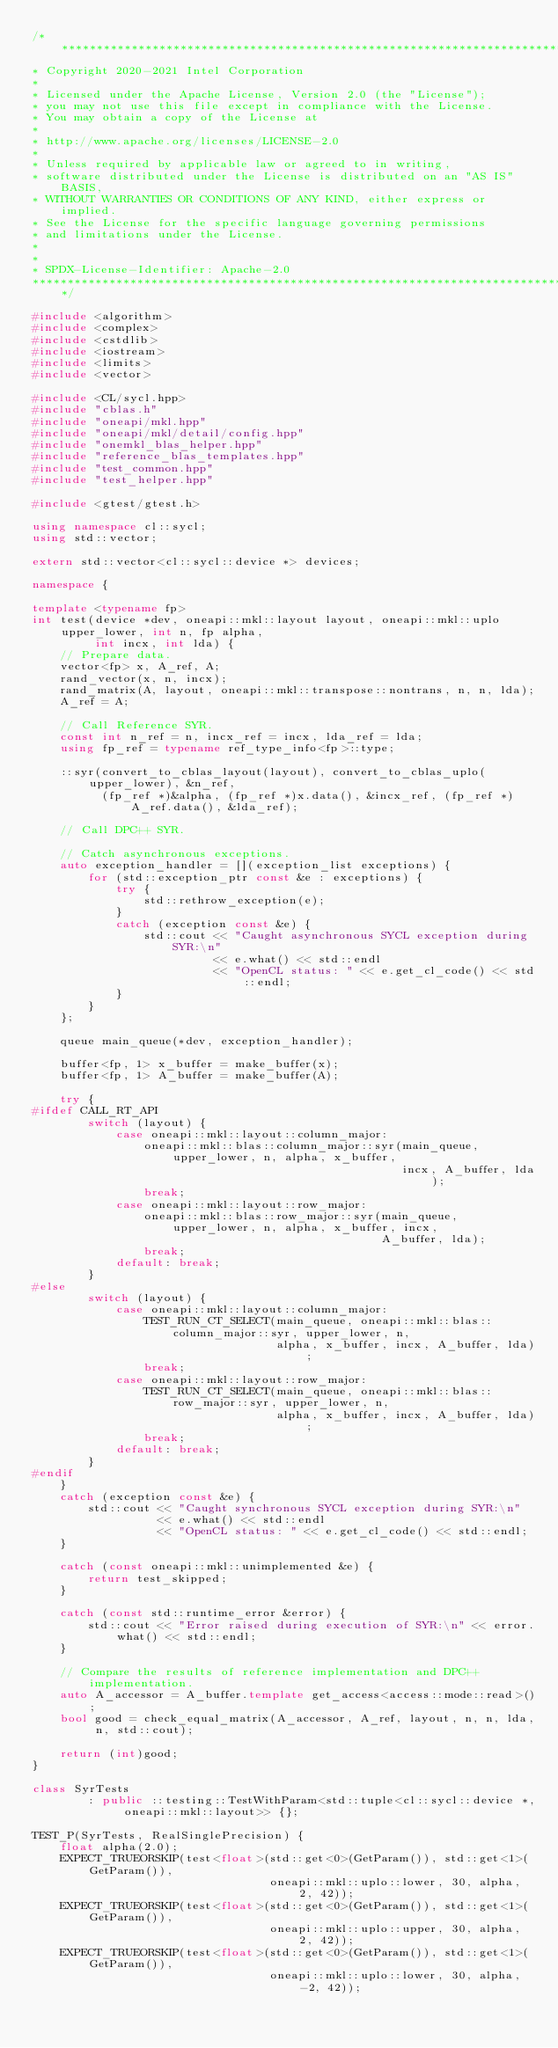Convert code to text. <code><loc_0><loc_0><loc_500><loc_500><_C++_>/*******************************************************************************
* Copyright 2020-2021 Intel Corporation
*
* Licensed under the Apache License, Version 2.0 (the "License");
* you may not use this file except in compliance with the License.
* You may obtain a copy of the License at
*
* http://www.apache.org/licenses/LICENSE-2.0
*
* Unless required by applicable law or agreed to in writing,
* software distributed under the License is distributed on an "AS IS" BASIS,
* WITHOUT WARRANTIES OR CONDITIONS OF ANY KIND, either express or implied.
* See the License for the specific language governing permissions
* and limitations under the License.
*
*
* SPDX-License-Identifier: Apache-2.0
*******************************************************************************/

#include <algorithm>
#include <complex>
#include <cstdlib>
#include <iostream>
#include <limits>
#include <vector>

#include <CL/sycl.hpp>
#include "cblas.h"
#include "oneapi/mkl.hpp"
#include "oneapi/mkl/detail/config.hpp"
#include "onemkl_blas_helper.hpp"
#include "reference_blas_templates.hpp"
#include "test_common.hpp"
#include "test_helper.hpp"

#include <gtest/gtest.h>

using namespace cl::sycl;
using std::vector;

extern std::vector<cl::sycl::device *> devices;

namespace {

template <typename fp>
int test(device *dev, oneapi::mkl::layout layout, oneapi::mkl::uplo upper_lower, int n, fp alpha,
         int incx, int lda) {
    // Prepare data.
    vector<fp> x, A_ref, A;
    rand_vector(x, n, incx);
    rand_matrix(A, layout, oneapi::mkl::transpose::nontrans, n, n, lda);
    A_ref = A;

    // Call Reference SYR.
    const int n_ref = n, incx_ref = incx, lda_ref = lda;
    using fp_ref = typename ref_type_info<fp>::type;

    ::syr(convert_to_cblas_layout(layout), convert_to_cblas_uplo(upper_lower), &n_ref,
          (fp_ref *)&alpha, (fp_ref *)x.data(), &incx_ref, (fp_ref *)A_ref.data(), &lda_ref);

    // Call DPC++ SYR.

    // Catch asynchronous exceptions.
    auto exception_handler = [](exception_list exceptions) {
        for (std::exception_ptr const &e : exceptions) {
            try {
                std::rethrow_exception(e);
            }
            catch (exception const &e) {
                std::cout << "Caught asynchronous SYCL exception during SYR:\n"
                          << e.what() << std::endl
                          << "OpenCL status: " << e.get_cl_code() << std::endl;
            }
        }
    };

    queue main_queue(*dev, exception_handler);

    buffer<fp, 1> x_buffer = make_buffer(x);
    buffer<fp, 1> A_buffer = make_buffer(A);

    try {
#ifdef CALL_RT_API
        switch (layout) {
            case oneapi::mkl::layout::column_major:
                oneapi::mkl::blas::column_major::syr(main_queue, upper_lower, n, alpha, x_buffer,
                                                     incx, A_buffer, lda);
                break;
            case oneapi::mkl::layout::row_major:
                oneapi::mkl::blas::row_major::syr(main_queue, upper_lower, n, alpha, x_buffer, incx,
                                                  A_buffer, lda);
                break;
            default: break;
        }
#else
        switch (layout) {
            case oneapi::mkl::layout::column_major:
                TEST_RUN_CT_SELECT(main_queue, oneapi::mkl::blas::column_major::syr, upper_lower, n,
                                   alpha, x_buffer, incx, A_buffer, lda);
                break;
            case oneapi::mkl::layout::row_major:
                TEST_RUN_CT_SELECT(main_queue, oneapi::mkl::blas::row_major::syr, upper_lower, n,
                                   alpha, x_buffer, incx, A_buffer, lda);
                break;
            default: break;
        }
#endif
    }
    catch (exception const &e) {
        std::cout << "Caught synchronous SYCL exception during SYR:\n"
                  << e.what() << std::endl
                  << "OpenCL status: " << e.get_cl_code() << std::endl;
    }

    catch (const oneapi::mkl::unimplemented &e) {
        return test_skipped;
    }

    catch (const std::runtime_error &error) {
        std::cout << "Error raised during execution of SYR:\n" << error.what() << std::endl;
    }

    // Compare the results of reference implementation and DPC++ implementation.
    auto A_accessor = A_buffer.template get_access<access::mode::read>();
    bool good = check_equal_matrix(A_accessor, A_ref, layout, n, n, lda, n, std::cout);

    return (int)good;
}

class SyrTests
        : public ::testing::TestWithParam<std::tuple<cl::sycl::device *, oneapi::mkl::layout>> {};

TEST_P(SyrTests, RealSinglePrecision) {
    float alpha(2.0);
    EXPECT_TRUEORSKIP(test<float>(std::get<0>(GetParam()), std::get<1>(GetParam()),
                                  oneapi::mkl::uplo::lower, 30, alpha, 2, 42));
    EXPECT_TRUEORSKIP(test<float>(std::get<0>(GetParam()), std::get<1>(GetParam()),
                                  oneapi::mkl::uplo::upper, 30, alpha, 2, 42));
    EXPECT_TRUEORSKIP(test<float>(std::get<0>(GetParam()), std::get<1>(GetParam()),
                                  oneapi::mkl::uplo::lower, 30, alpha, -2, 42));</code> 